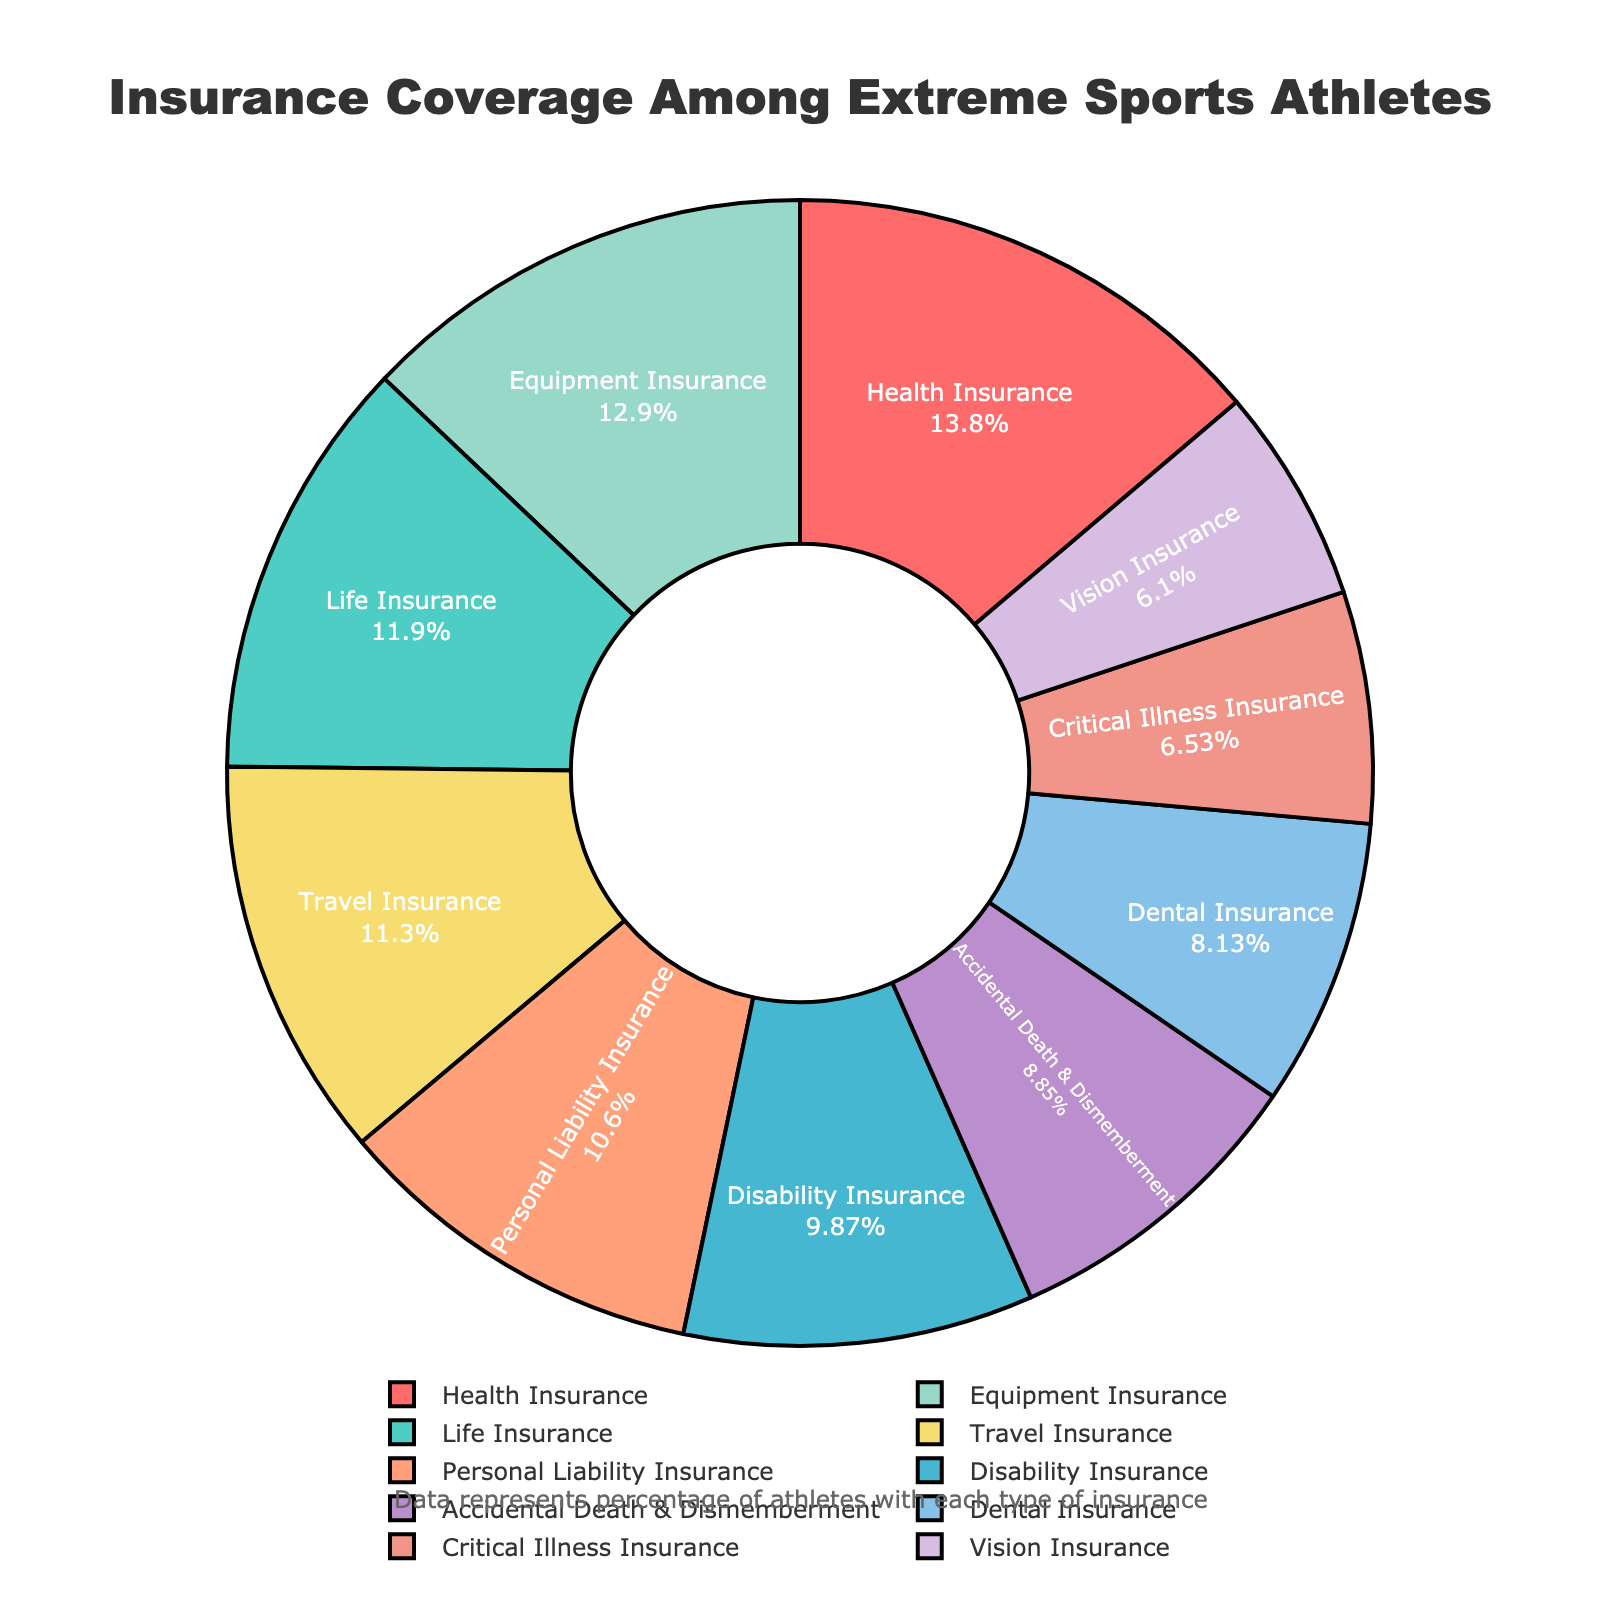Which insurance type is the most common among extreme sports athletes? Look at the sector with the highest percentage, which represents the most common insurance type. Health Insurance has the highest percentage at 95%.
Answer: Health Insurance Which insurance type has the lowest coverage among extreme sports athletes? Identify the sector with the smallest percentage, representing the least common insurance type. Vision Insurance has the lowest percentage at 42%.
Answer: Vision Insurance What is the difference in coverage percentage between Life Insurance and Disability Insurance? Subtract the percentage of Disability Insurance from that of Life Insurance: 82 - 68 = 14.
Answer: 14 Which has a higher coverage percentage: Travel Insurance or Equipment Insurance? Compare the percentages of Travel Insurance (78%) and Equipment Insurance (89%).
Answer: Equipment Insurance Are there more athletes covered by Dental Insurance or Critical Illness Insurance? Compare the percentage values of Dental Insurance (56%) and Critical Illness Insurance (45%). Dental Insurance has a higher coverage percentage.
Answer: Dental Insurance What is the total percentage of athletes covered by Life Insurance, Travel Insurance, and Accidental Death & Dismemberment Insurance? Add the percentages of Life Insurance (82%), Travel Insurance (78%), and Accidental Death & Dismemberment Insurance (61%): 82 + 78 + 61 = 221.
Answer: 221 How much higher is the coverage percentage for Health Insurance compared to Vision Insurance? Subtract the percentage of Vision Insurance from that of Health Insurance: 95 - 42 = 53.
Answer: 53 Which has greater coverage: Personal Liability Insurance or the combined coverage of Dental Insurance and Vision Insurance? Compare the percentage of Personal Liability Insurance (73%) with the combined percentage of Dental Insurance (56%) and Vision Insurance (42%): 56 + 42 = 98.
Answer: Combined coverage of Dental Insurance and Vision Insurance What color represents the Equipment Insurance sector in the pie chart? Identify the color used for Equipment Insurance in the chart. The segment corresponding to Equipment Insurance is colored light green.
Answer: Light Green Which insurance type is distinguished by the color red in the pie chart? Identify the insurance type that is visually represented by the color red. The sector for Health Insurance is colored red.
Answer: Health Insurance 